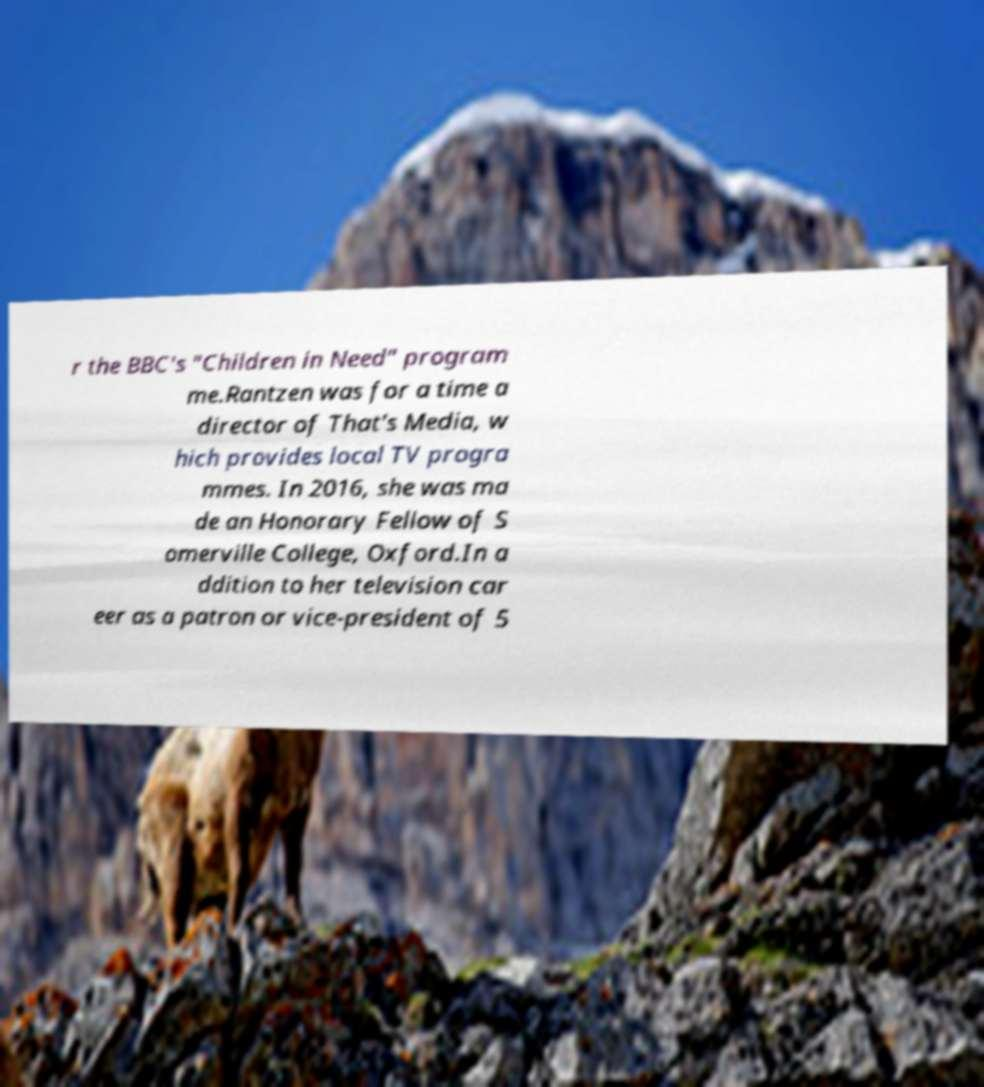Can you read and provide the text displayed in the image?This photo seems to have some interesting text. Can you extract and type it out for me? r the BBC's "Children in Need" program me.Rantzen was for a time a director of That's Media, w hich provides local TV progra mmes. In 2016, she was ma de an Honorary Fellow of S omerville College, Oxford.In a ddition to her television car eer as a patron or vice-president of 5 